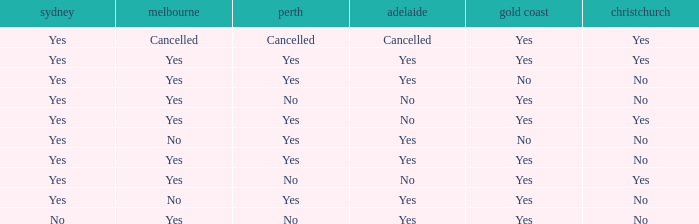What is the sydney that has adelaide, gold coast, melbourne, and auckland are all yes? Yes. 